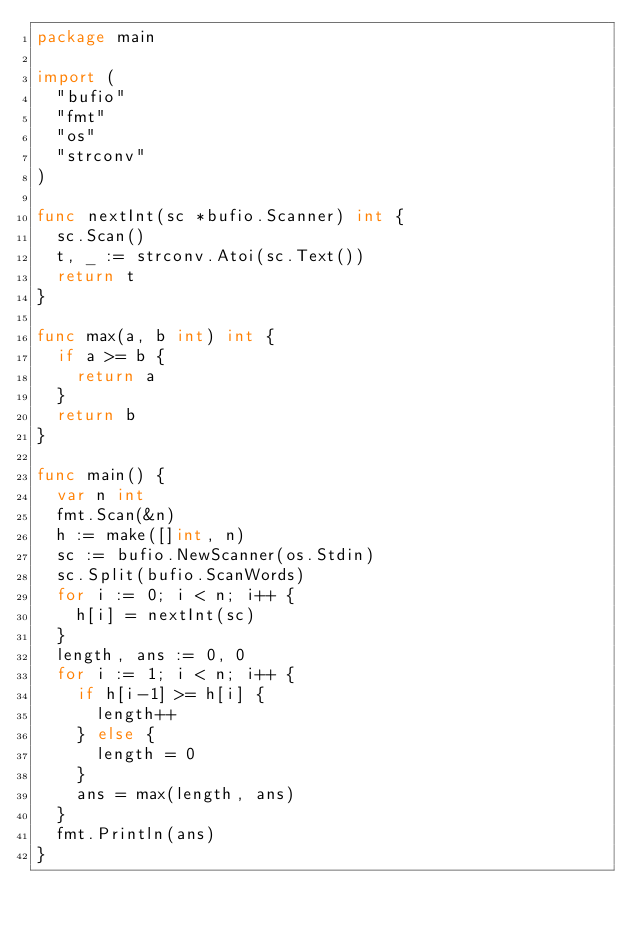Convert code to text. <code><loc_0><loc_0><loc_500><loc_500><_Go_>package main

import (
	"bufio"
	"fmt"
	"os"
	"strconv"
)

func nextInt(sc *bufio.Scanner) int {
	sc.Scan()
	t, _ := strconv.Atoi(sc.Text())
	return t
}

func max(a, b int) int {
	if a >= b {
		return a
	}
	return b
}

func main() {
	var n int
	fmt.Scan(&n)
	h := make([]int, n)
	sc := bufio.NewScanner(os.Stdin)
	sc.Split(bufio.ScanWords)
	for i := 0; i < n; i++ {
		h[i] = nextInt(sc)
	}
	length, ans := 0, 0
	for i := 1; i < n; i++ {
		if h[i-1] >= h[i] {
			length++
		} else {
			length = 0
		}
		ans = max(length, ans)
	}
	fmt.Println(ans)
}
</code> 